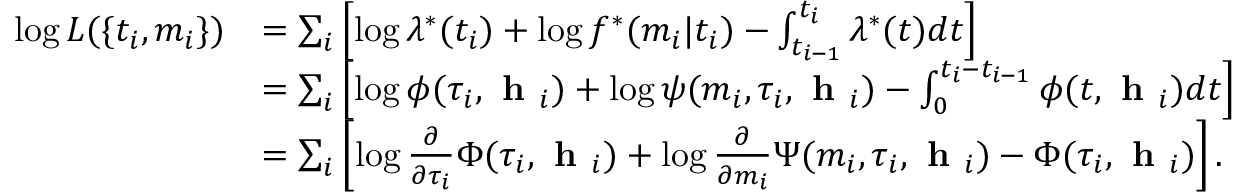Convert formula to latex. <formula><loc_0><loc_0><loc_500><loc_500>\begin{array} { r l } { \log L ( \{ t _ { i } , m _ { i } \} ) } & { = \sum _ { i } \left [ \log \lambda ^ { * } ( t _ { i } ) + \log f ^ { * } ( m _ { i } | t _ { i } ) - \int _ { t _ { i - 1 } } ^ { t _ { i } } \lambda ^ { * } ( t ) d t \right ] } \\ & { = \sum _ { i } \left [ \log \phi ( \tau _ { i } , h _ { i } ) + \log \psi ( m _ { i } , \tau _ { i } , h _ { i } ) - \int _ { 0 } ^ { t _ { i } - t _ { i - 1 } } \phi ( t , h _ { i } ) d t \right ] } \\ & { = \sum _ { i } \left [ \log \frac { \partial } { \partial \tau _ { i } } \Phi ( \tau _ { i } , h _ { i } ) + \log \frac { \partial } { \partial m _ { i } } \Psi ( m _ { i } , \tau _ { i } , h _ { i } ) - \Phi ( \tau _ { i } , h _ { i } ) \right ] . } \end{array}</formula> 